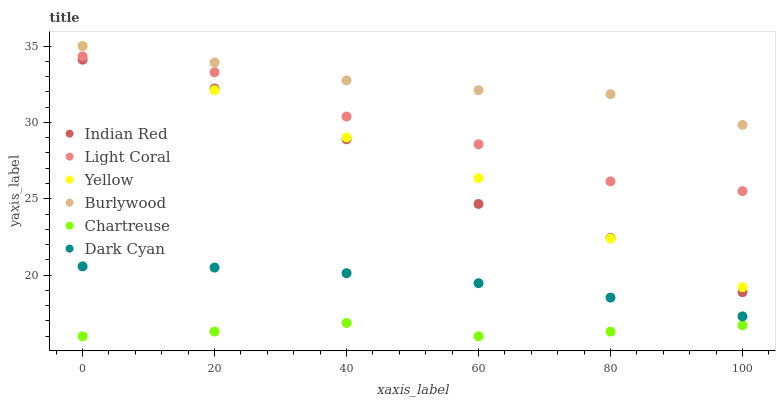Does Chartreuse have the minimum area under the curve?
Answer yes or no. Yes. Does Burlywood have the maximum area under the curve?
Answer yes or no. Yes. Does Yellow have the minimum area under the curve?
Answer yes or no. No. Does Yellow have the maximum area under the curve?
Answer yes or no. No. Is Dark Cyan the smoothest?
Answer yes or no. Yes. Is Indian Red the roughest?
Answer yes or no. Yes. Is Yellow the smoothest?
Answer yes or no. No. Is Yellow the roughest?
Answer yes or no. No. Does Chartreuse have the lowest value?
Answer yes or no. Yes. Does Yellow have the lowest value?
Answer yes or no. No. Does Yellow have the highest value?
Answer yes or no. Yes. Does Light Coral have the highest value?
Answer yes or no. No. Is Chartreuse less than Burlywood?
Answer yes or no. Yes. Is Light Coral greater than Indian Red?
Answer yes or no. Yes. Does Yellow intersect Burlywood?
Answer yes or no. Yes. Is Yellow less than Burlywood?
Answer yes or no. No. Is Yellow greater than Burlywood?
Answer yes or no. No. Does Chartreuse intersect Burlywood?
Answer yes or no. No. 